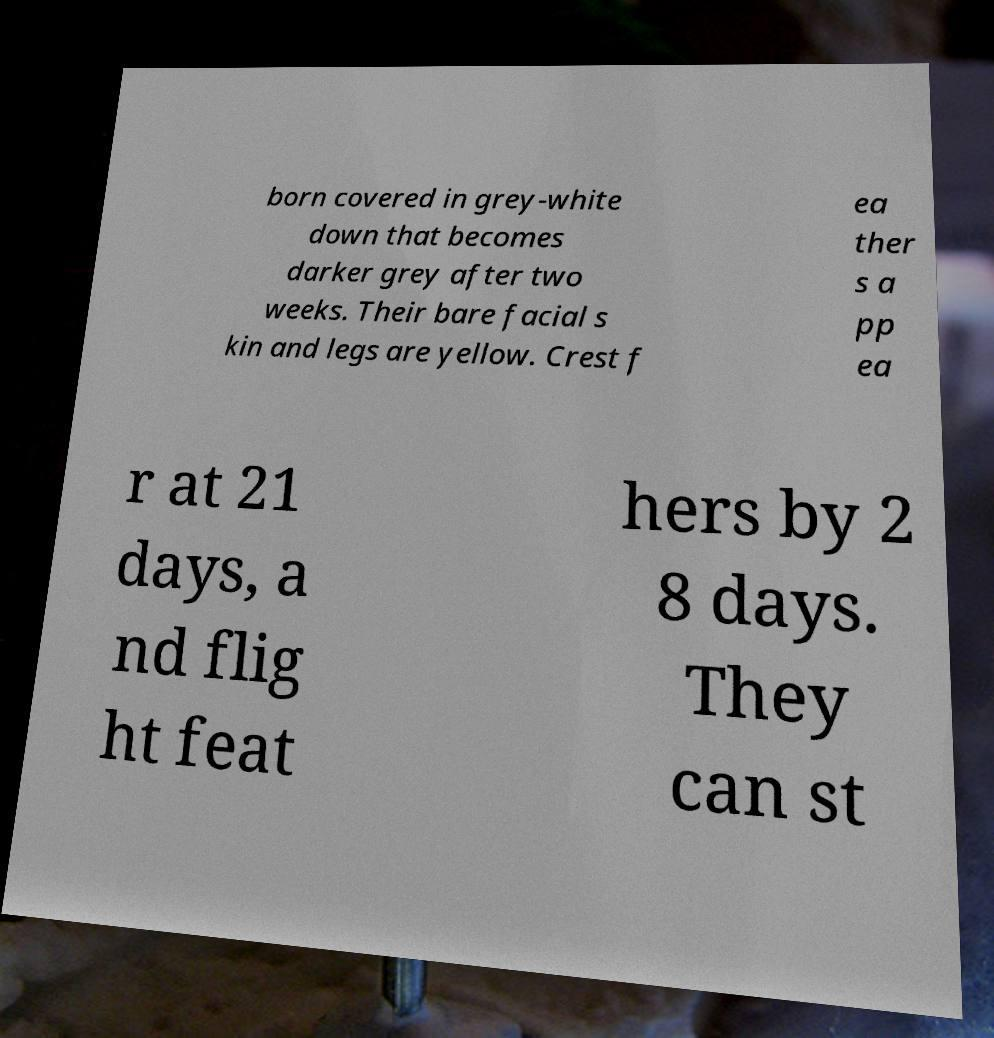There's text embedded in this image that I need extracted. Can you transcribe it verbatim? born covered in grey-white down that becomes darker grey after two weeks. Their bare facial s kin and legs are yellow. Crest f ea ther s a pp ea r at 21 days, a nd flig ht feat hers by 2 8 days. They can st 